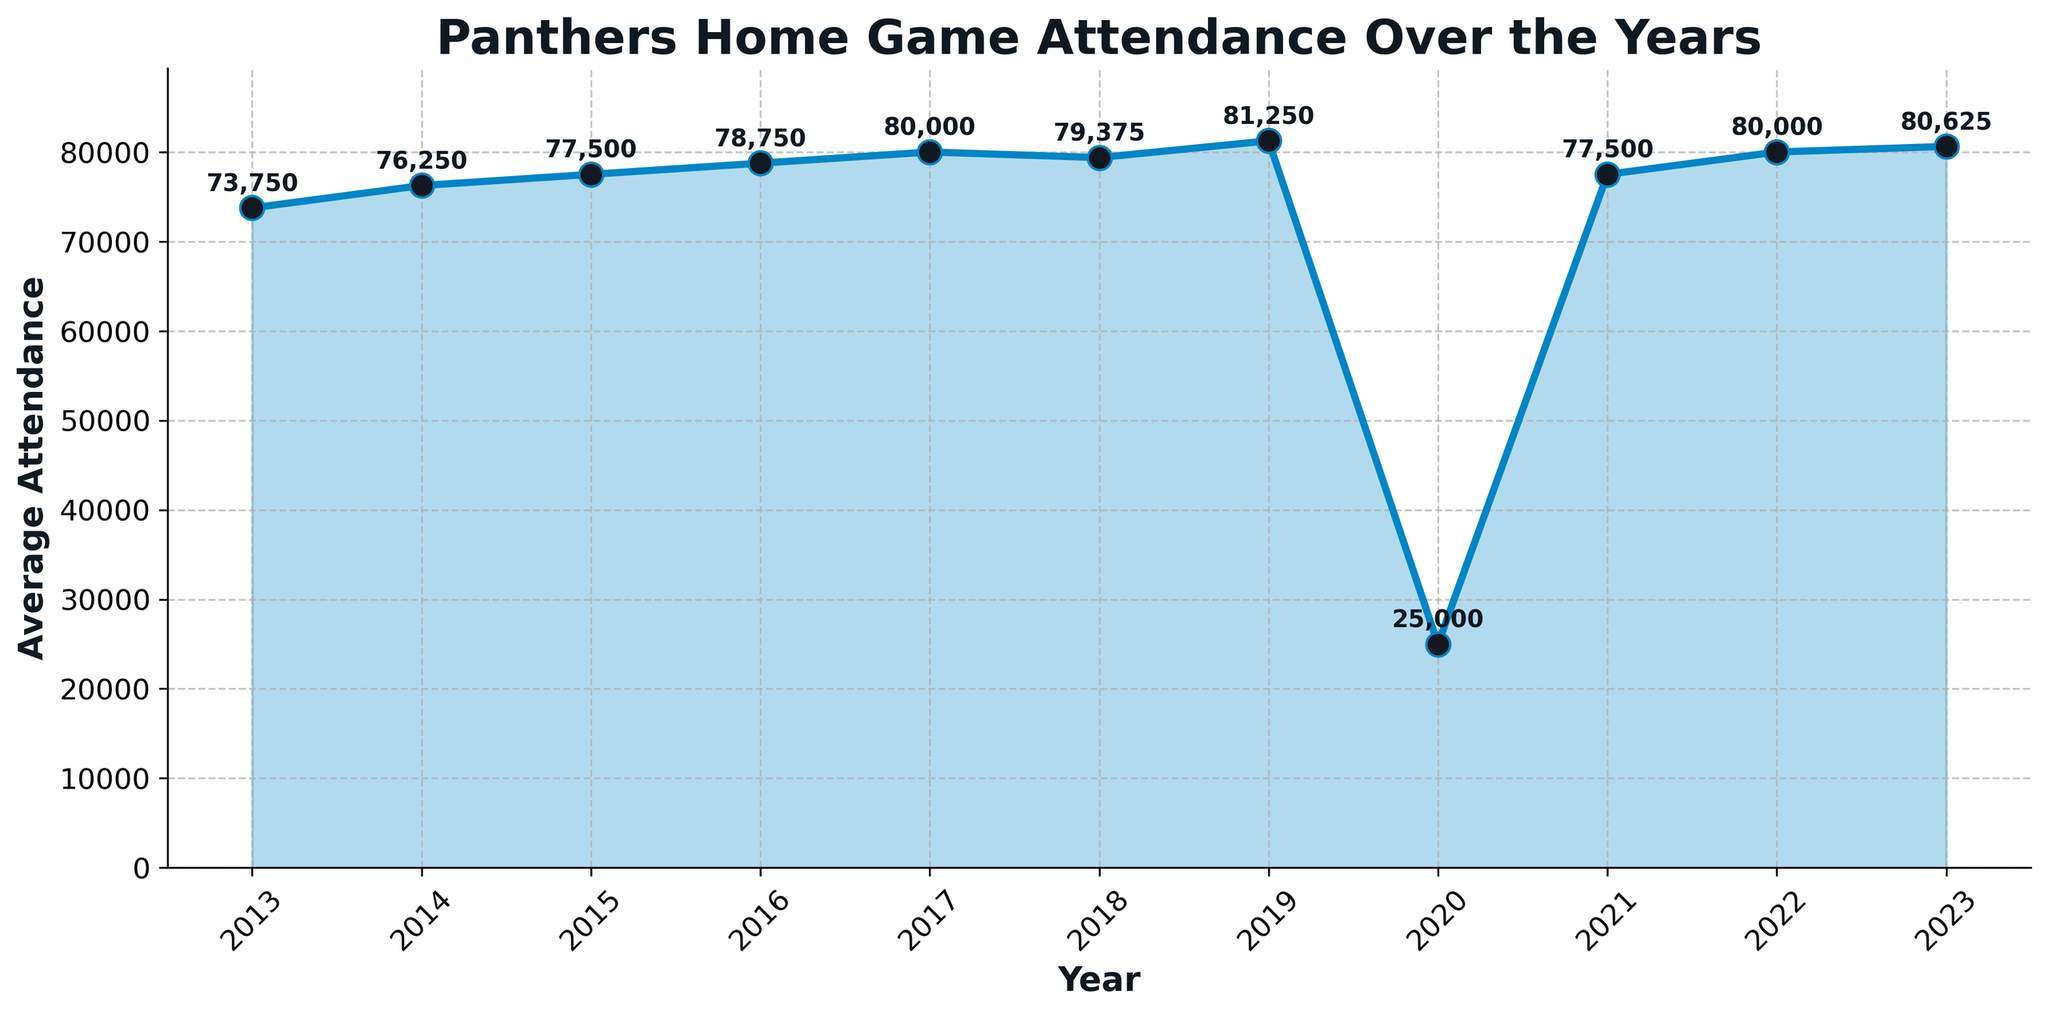What is the title of the plot? The title is usually displayed at the top of the plot. Here it says "Panthers Home Game Attendance Over the Years".
Answer: Panthers Home Game Attendance Over the Years How many years of data are represented in the plot? Count the number of data points on the x-axis. The years range from 2013 to 2023.
Answer: 11 Which year had the lowest average attendance? Scan the y-axis values and find the year that has the lowest point on the plot. It appears to be 2020.
Answer: 2020 Which year had the highest average attendance? Identify the highest point on the y-axis and note the corresponding year. This is in 2019.
Answer: 2019 What is the average attendance in 2017? Locate the data point for the year 2017 and see the annotation on the plot. It is 80,000.
Answer: 80,000 How does the average attendance in 2023 compare to 2013? Compare the final points on the x-axis for 2013 and 2023. The value in 2023 (80,625) is higher than in 2013 (73,750).
Answer: Higher What is the difference in average attendance between 2019 and 2020? Subtract the average attendance value in 2020 (25,000) from the value in 2019 (81,250).
Answer: 56,250 What trend can be observed from 2013 to 2019? Analyze the plot's slope from 2013 to 2019. The average attendance figures show an increasing trend.
Answer: Increasing trend What was the total attendance for the 2021 season? Given that the average attendance in 2021 is 77,500 and there are 8 games, multiply these values. 77500 * 8 = 620,000.
Answer: 620,000 How did the average attendance change from 2021 to 2022? Compare the average attendance in 2021 (77,500) to that in 2022 (80,000). The difference is 80,000 - 77,500 = 2,500.
Answer: Increased by 2,500 